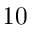Convert formula to latex. <formula><loc_0><loc_0><loc_500><loc_500>1 0</formula> 